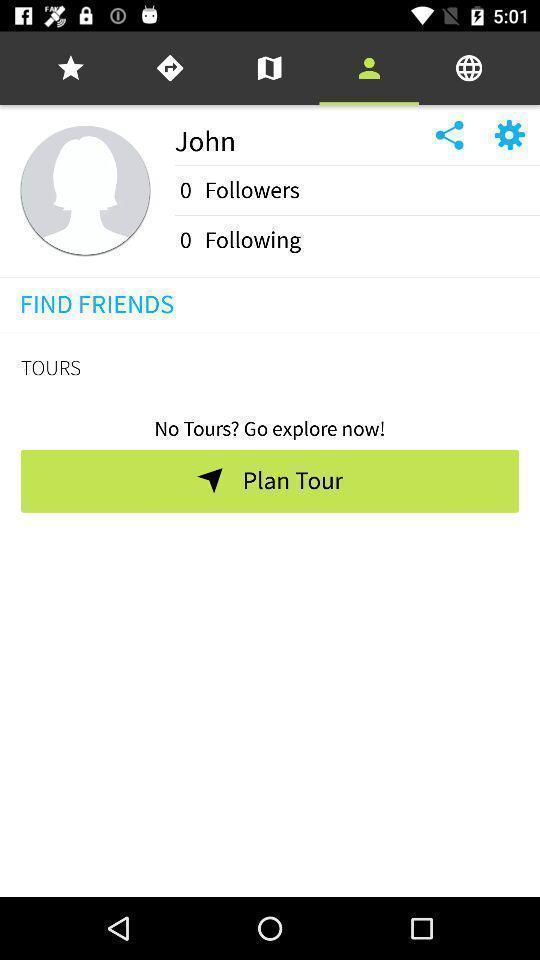Describe the key features of this screenshot. Profile page of a social app. 